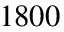Convert formula to latex. <formula><loc_0><loc_0><loc_500><loc_500>1 8 0 0</formula> 